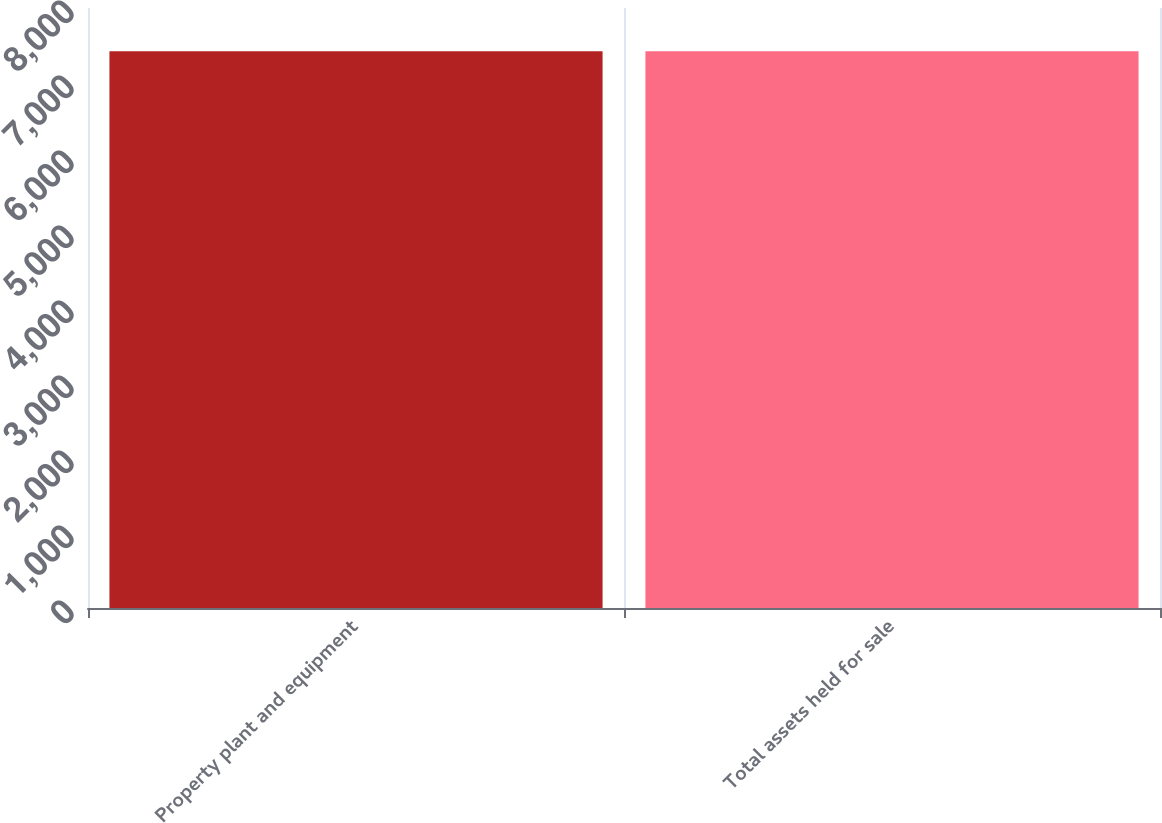Convert chart. <chart><loc_0><loc_0><loc_500><loc_500><bar_chart><fcel>Property plant and equipment<fcel>Total assets held for sale<nl><fcel>7422<fcel>7422.1<nl></chart> 